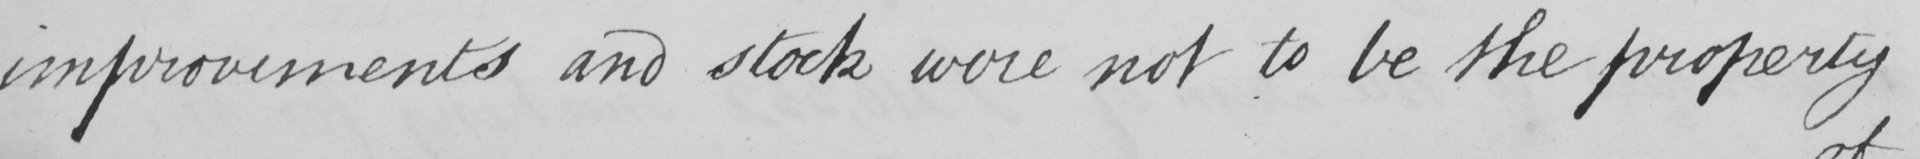What is written in this line of handwriting? improvements and stock were not to be the property 